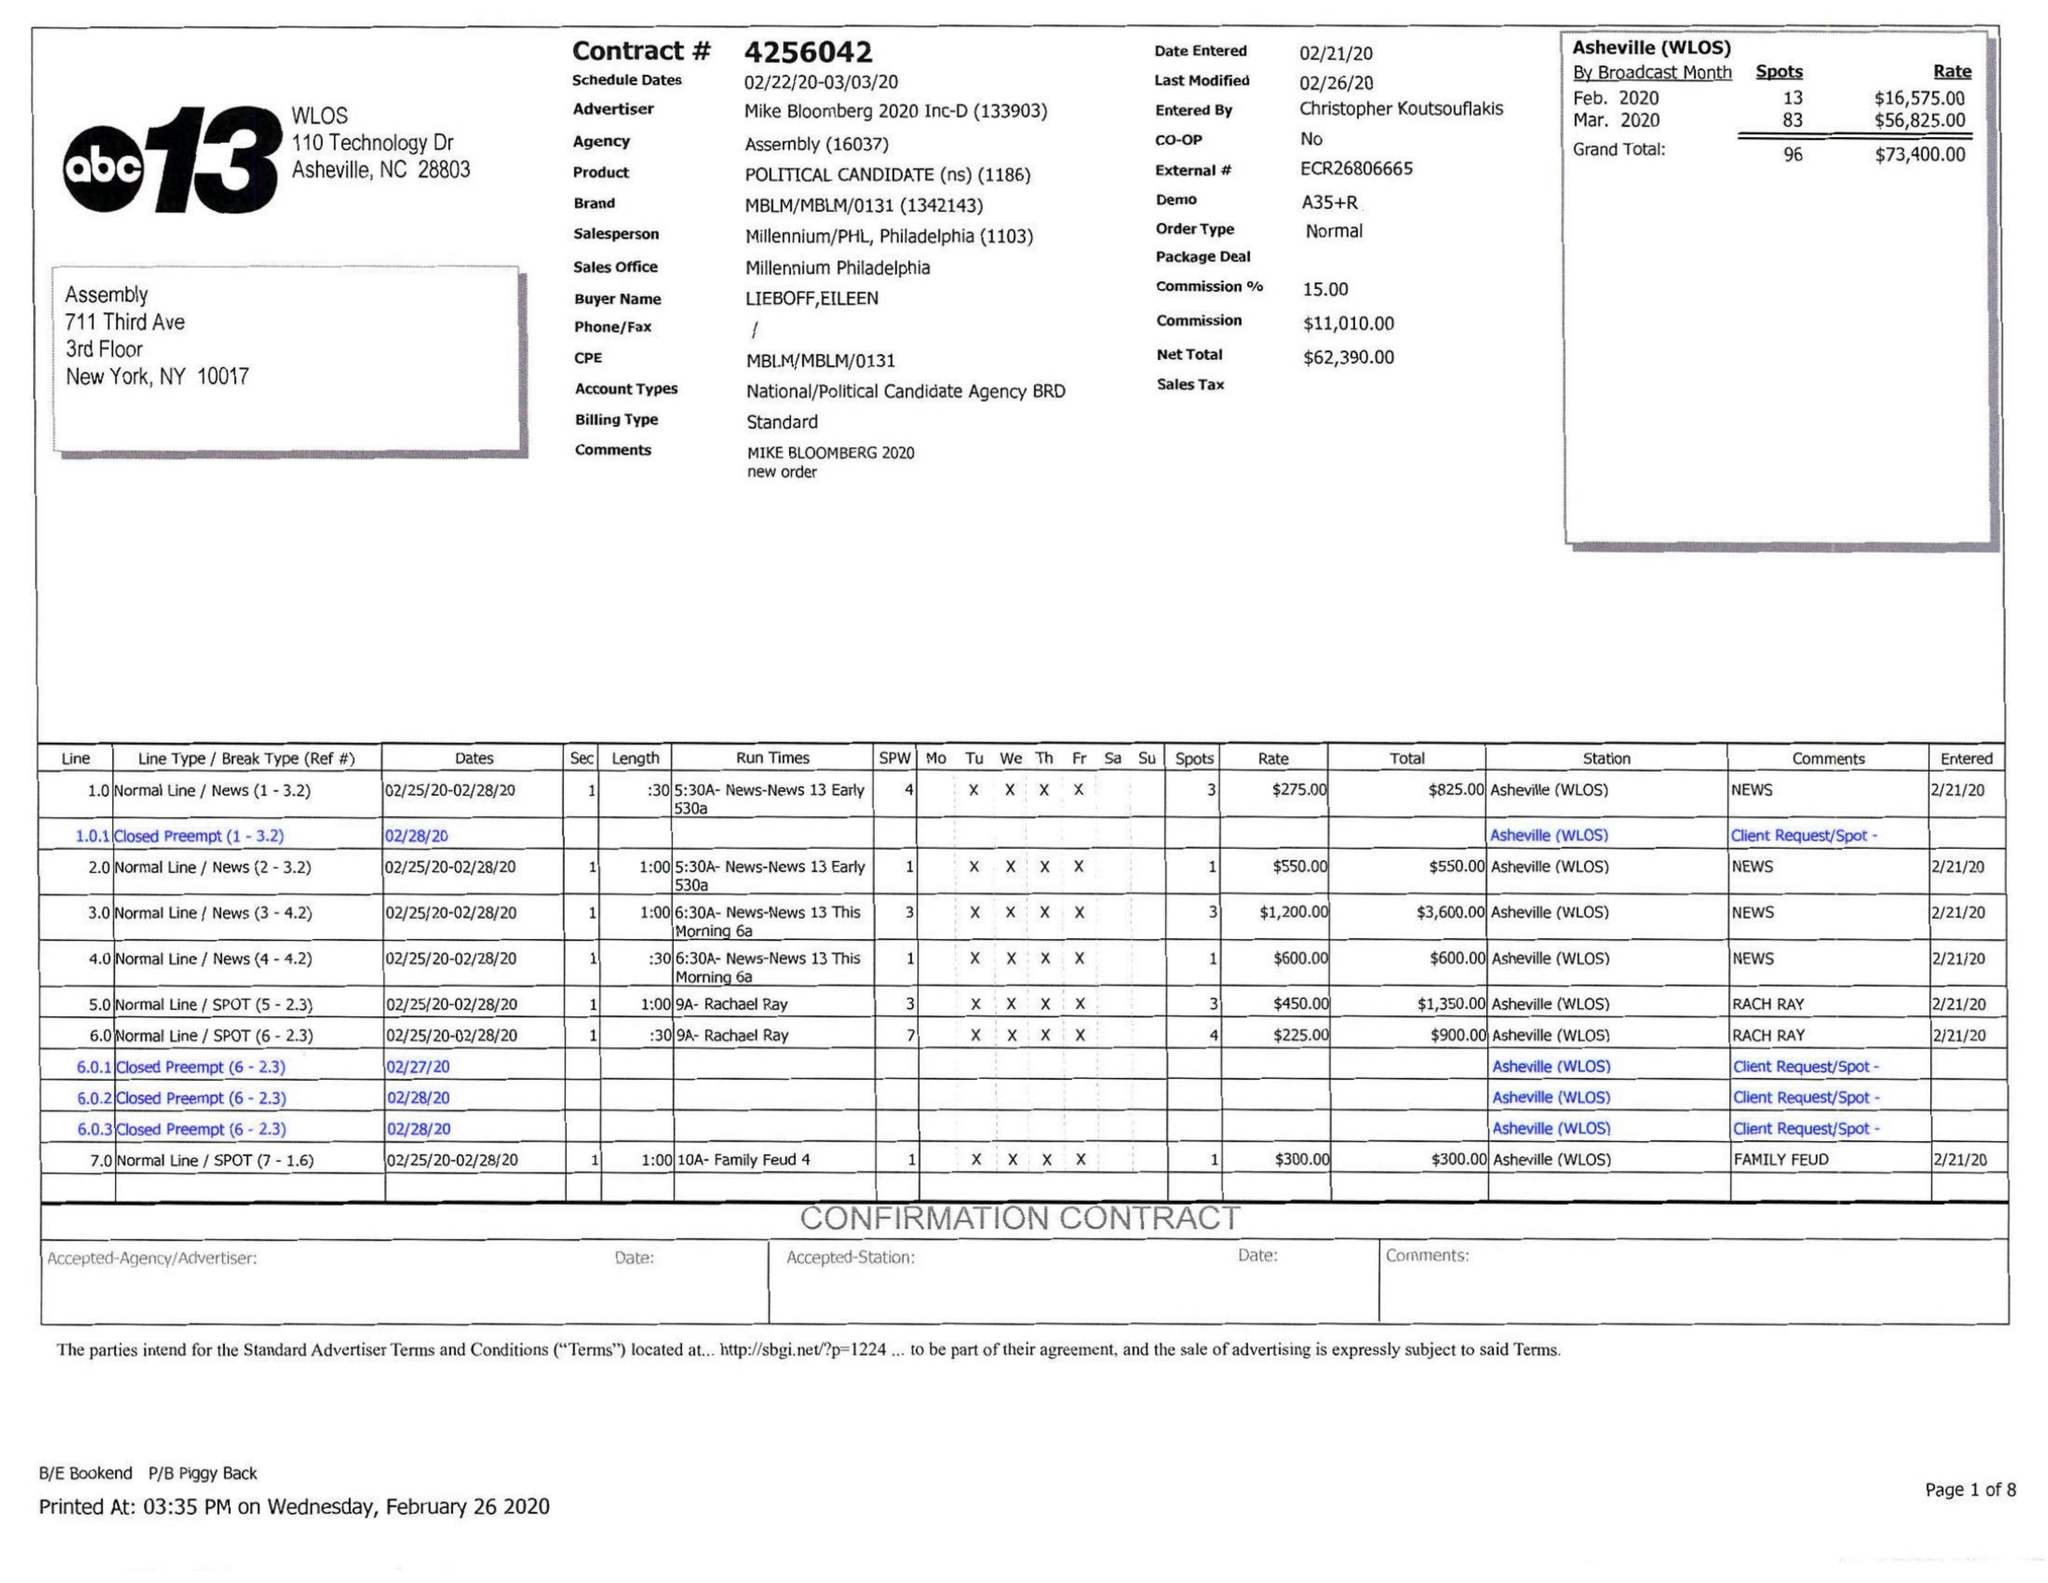What is the value for the gross_amount?
Answer the question using a single word or phrase. 73400.00 